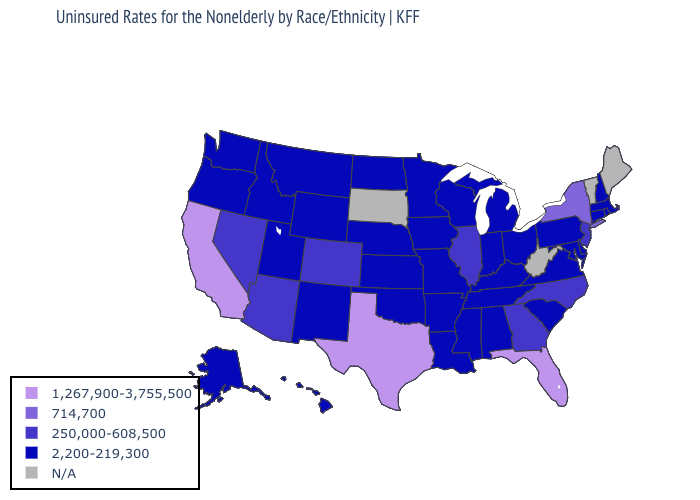Name the states that have a value in the range 1,267,900-3,755,500?
Give a very brief answer. California, Florida, Texas. Is the legend a continuous bar?
Give a very brief answer. No. Name the states that have a value in the range 2,200-219,300?
Answer briefly. Alabama, Alaska, Arkansas, Connecticut, Delaware, Hawaii, Idaho, Indiana, Iowa, Kansas, Kentucky, Louisiana, Maryland, Massachusetts, Michigan, Minnesota, Mississippi, Missouri, Montana, Nebraska, New Hampshire, New Mexico, North Dakota, Ohio, Oklahoma, Oregon, Pennsylvania, Rhode Island, South Carolina, Tennessee, Utah, Virginia, Washington, Wisconsin, Wyoming. Name the states that have a value in the range 250,000-608,500?
Write a very short answer. Arizona, Colorado, Georgia, Illinois, Nevada, New Jersey, North Carolina. Which states have the lowest value in the MidWest?
Keep it brief. Indiana, Iowa, Kansas, Michigan, Minnesota, Missouri, Nebraska, North Dakota, Ohio, Wisconsin. Name the states that have a value in the range 2,200-219,300?
Concise answer only. Alabama, Alaska, Arkansas, Connecticut, Delaware, Hawaii, Idaho, Indiana, Iowa, Kansas, Kentucky, Louisiana, Maryland, Massachusetts, Michigan, Minnesota, Mississippi, Missouri, Montana, Nebraska, New Hampshire, New Mexico, North Dakota, Ohio, Oklahoma, Oregon, Pennsylvania, Rhode Island, South Carolina, Tennessee, Utah, Virginia, Washington, Wisconsin, Wyoming. Which states have the lowest value in the USA?
Give a very brief answer. Alabama, Alaska, Arkansas, Connecticut, Delaware, Hawaii, Idaho, Indiana, Iowa, Kansas, Kentucky, Louisiana, Maryland, Massachusetts, Michigan, Minnesota, Mississippi, Missouri, Montana, Nebraska, New Hampshire, New Mexico, North Dakota, Ohio, Oklahoma, Oregon, Pennsylvania, Rhode Island, South Carolina, Tennessee, Utah, Virginia, Washington, Wisconsin, Wyoming. Is the legend a continuous bar?
Be succinct. No. What is the value of Michigan?
Keep it brief. 2,200-219,300. Is the legend a continuous bar?
Answer briefly. No. What is the highest value in the USA?
Write a very short answer. 1,267,900-3,755,500. What is the value of Connecticut?
Short answer required. 2,200-219,300. 